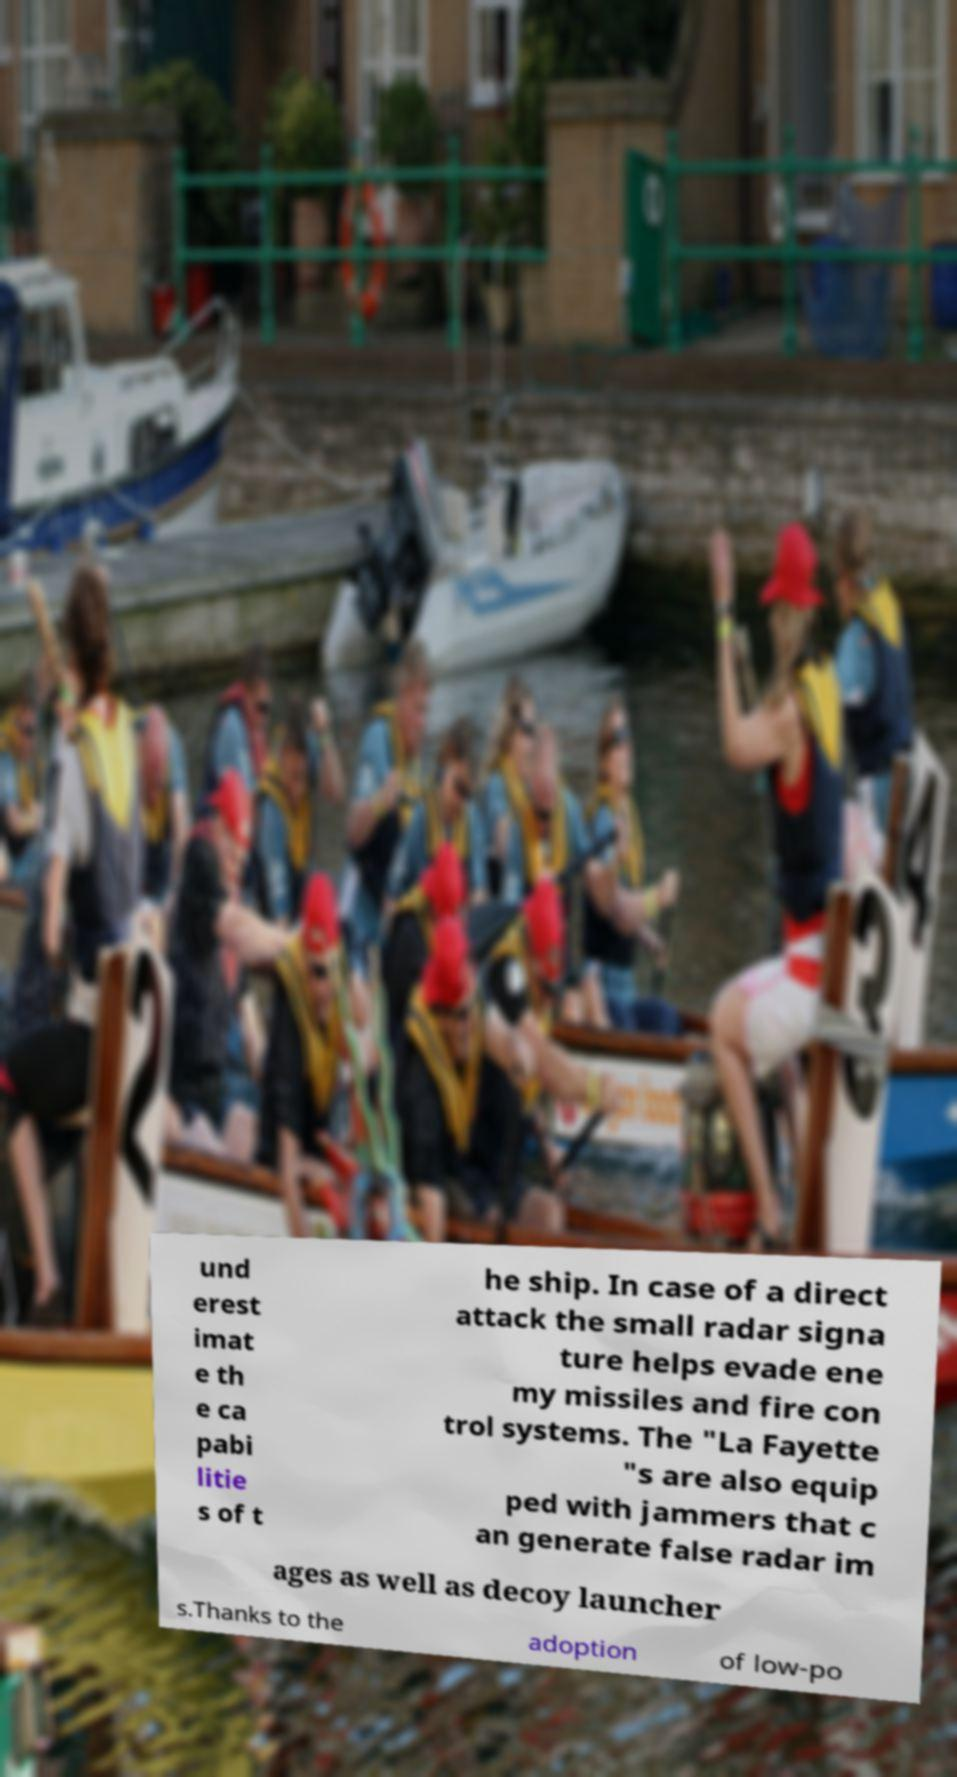Could you assist in decoding the text presented in this image and type it out clearly? und erest imat e th e ca pabi litie s of t he ship. In case of a direct attack the small radar signa ture helps evade ene my missiles and fire con trol systems. The "La Fayette "s are also equip ped with jammers that c an generate false radar im ages as well as decoy launcher s.Thanks to the adoption of low-po 